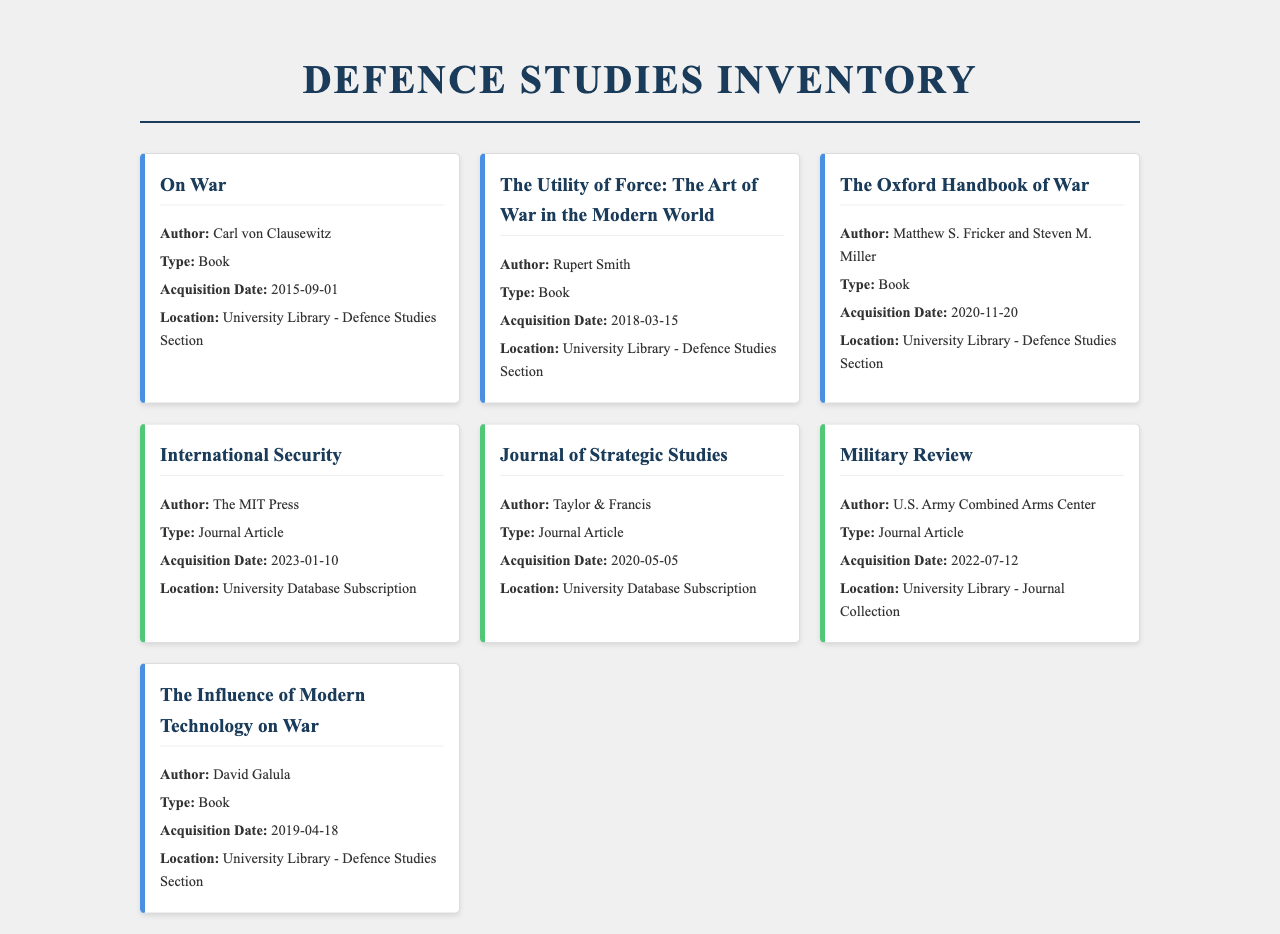What is the title of the first book listed? The title of the first book is the first item in the document, which is "On War."
Answer: On War Who is the author of "The Utility of Force"? The author can be found in the details of the book called "The Utility of Force," which is Rupert Smith.
Answer: Rupert Smith When was "The Oxford Handbook of War" acquired? The acquisition date for "The Oxford Handbook of War" is listed in the document under that book's details, which is 2020-11-20.
Answer: 2020-11-20 How many journal articles are listed in the inventory? The total number of journal articles can be counted from the inventory; there are three articles listed.
Answer: 3 Where can the journal article "Military Review" be found? The location for "Military Review" is specified in the details of that journal article, which states it is in the University Library - Journal Collection.
Answer: University Library - Journal Collection Which book was acquired on 2019-04-18? The book acquired on that date can be identified in the document; it is "The Influence of Modern Technology on War."
Answer: The Influence of Modern Technology on War What is the publication that "International Security" belongs to? The publication responsible for "International Security" is noted in the document, which is The MIT Press.
Answer: The MIT Press How many books are included in the inventory? By counting, all the books can be identified in the inventory; there are four books listed.
Answer: 4 